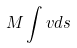Convert formula to latex. <formula><loc_0><loc_0><loc_500><loc_500>M \int v d s</formula> 